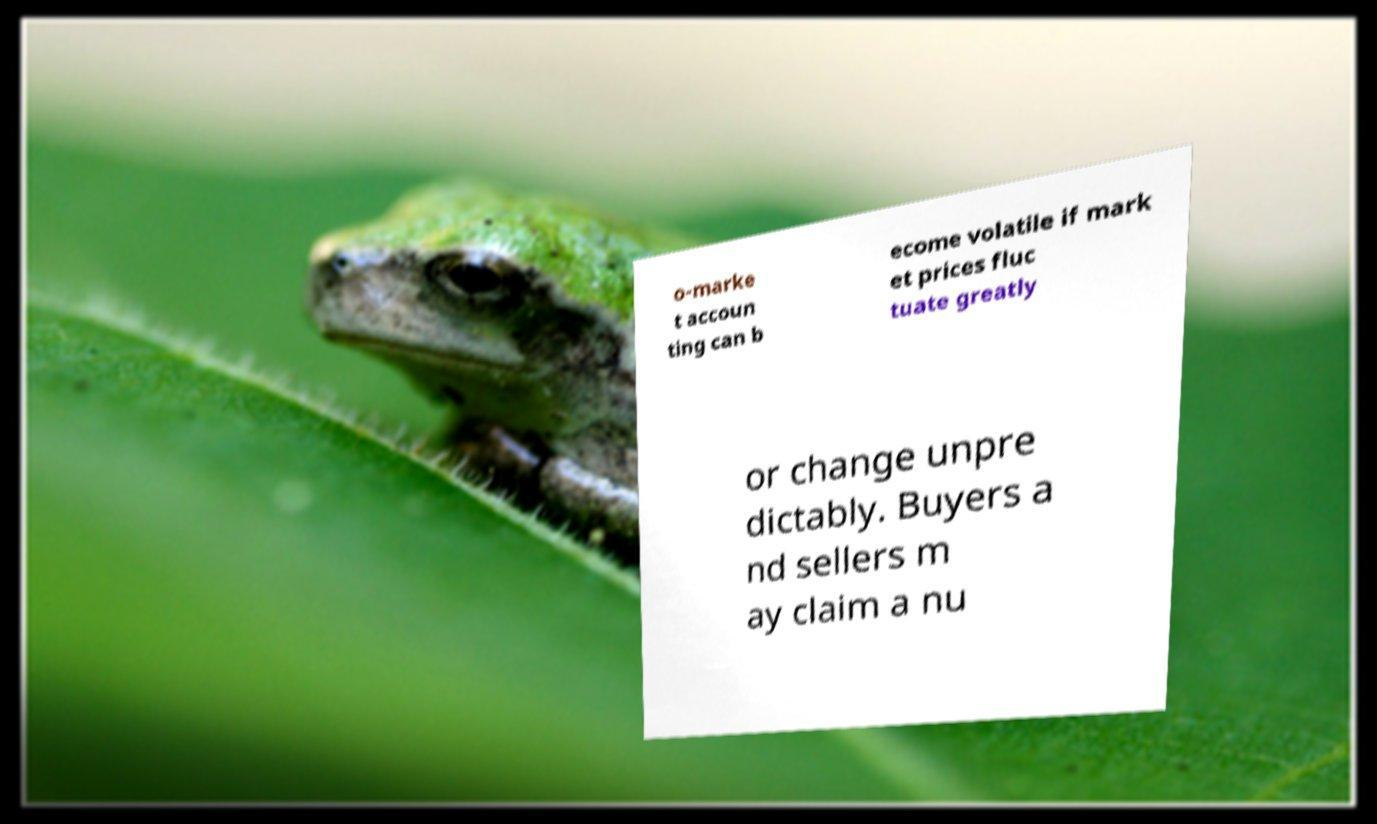Could you assist in decoding the text presented in this image and type it out clearly? o-marke t accoun ting can b ecome volatile if mark et prices fluc tuate greatly or change unpre dictably. Buyers a nd sellers m ay claim a nu 